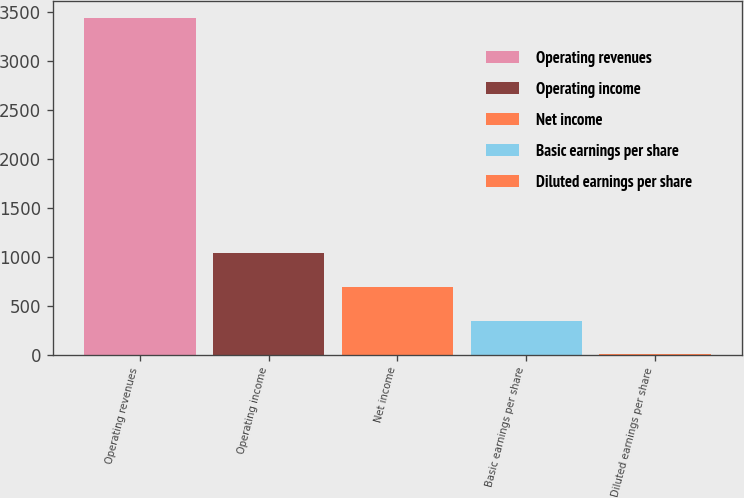Convert chart to OTSL. <chart><loc_0><loc_0><loc_500><loc_500><bar_chart><fcel>Operating revenues<fcel>Operating income<fcel>Net income<fcel>Basic earnings per share<fcel>Diluted earnings per share<nl><fcel>3443<fcel>1033.92<fcel>689.77<fcel>345.61<fcel>1.45<nl></chart> 